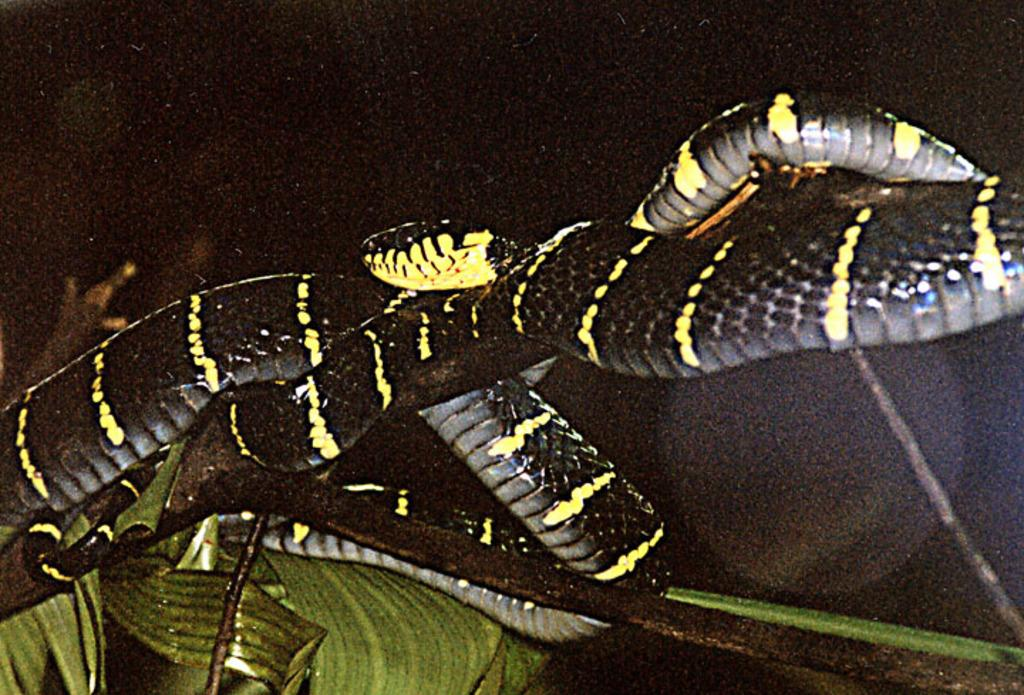What type of animal is in the image? There is a snake in the image. What is the snake resting on in the image? There is a branch in the image. What else can be seen in the image besides the snake and branch? There are leaves in the image. How would you describe the overall lighting in the image? The background of the image is dark. What disease does the snake have in the image? There is no indication of any disease in the image; the snake appears to be healthy. 